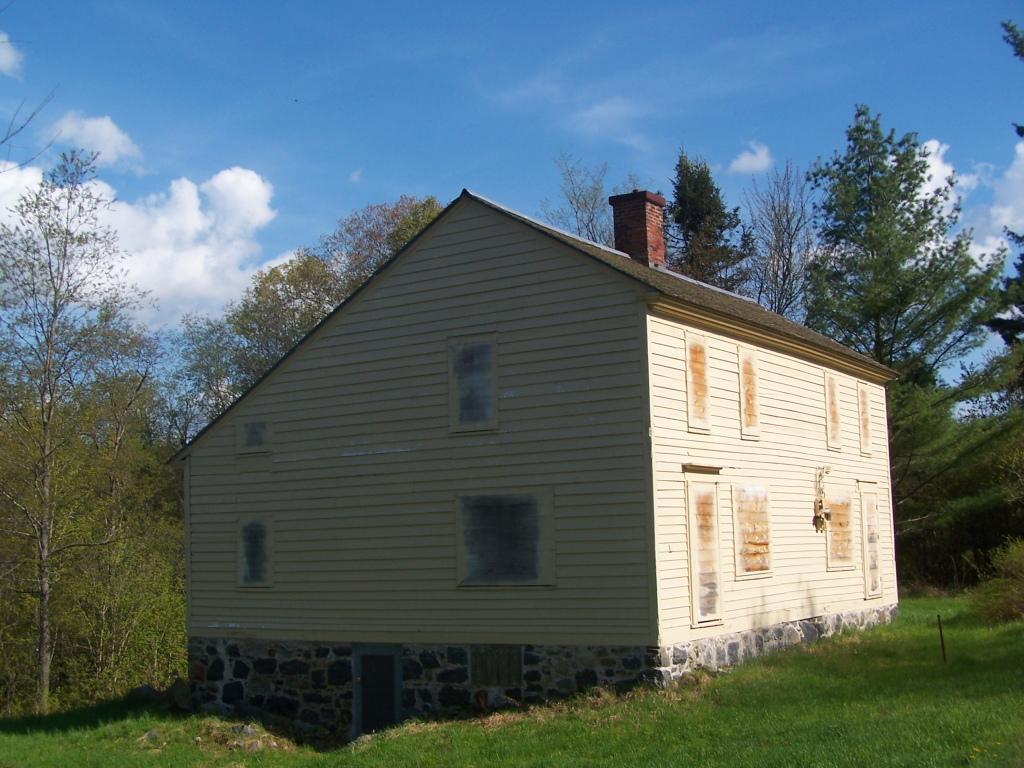Can you describe this image briefly? In this image I can see the hurt and there are windows to it. It is in cream color. In the background I can see many trees, clouds and the blue sky. 